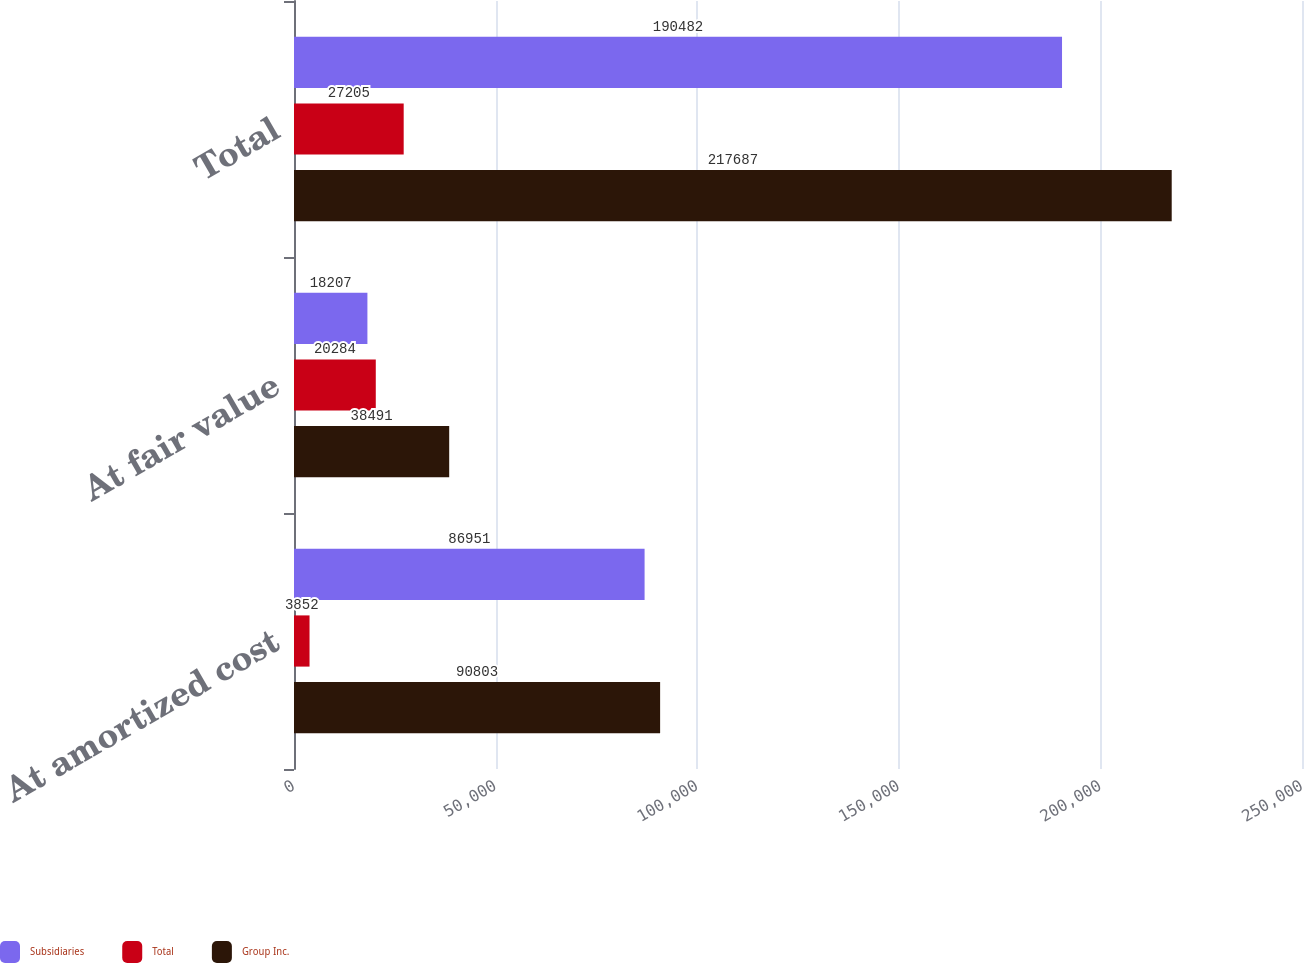Convert chart. <chart><loc_0><loc_0><loc_500><loc_500><stacked_bar_chart><ecel><fcel>At amortized cost<fcel>At fair value<fcel>Total<nl><fcel>Subsidiaries<fcel>86951<fcel>18207<fcel>190482<nl><fcel>Total<fcel>3852<fcel>20284<fcel>27205<nl><fcel>Group Inc.<fcel>90803<fcel>38491<fcel>217687<nl></chart> 